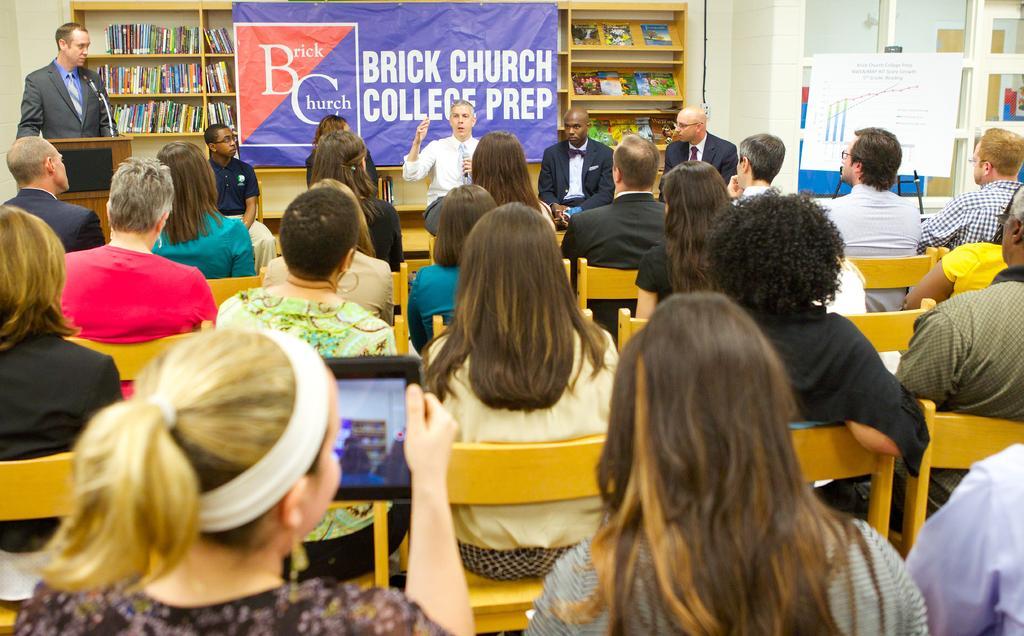How would you summarize this image in a sentence or two? In the picture we can see many people are sitting on the chairs and in front of them we can see a man standing and talking in the microphone and he is in white shirt and tie and beside him we can see two men are standing and they are in blazers and one man is standing on another side near the desk and in the background we can see a rack with full of books and banner to it. 